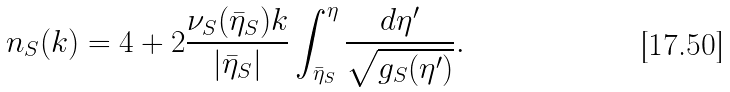<formula> <loc_0><loc_0><loc_500><loc_500>n _ { S } ( k ) = 4 + 2 \frac { \nu _ { S } ( \bar { \eta } _ { S } ) k } { | \bar { \eta } _ { S } | } \int _ { \bar { \eta } _ { S } } ^ { \eta } \frac { d \eta ^ { \prime } } { \sqrt { g _ { S } ( \eta ^ { \prime } ) } } .</formula> 